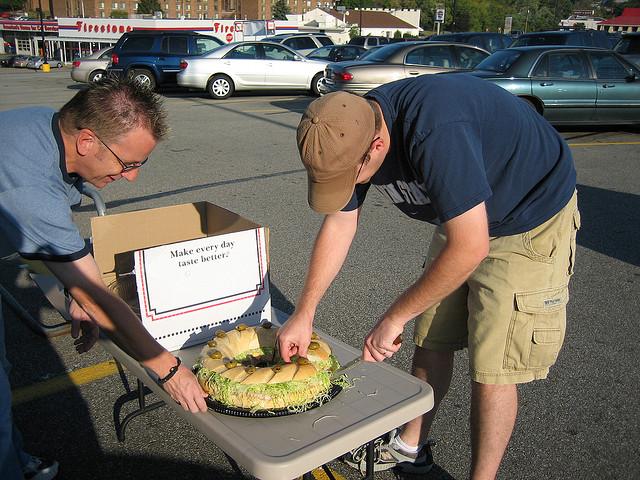What is sitting next to the sandwich?
Quick response, please. Box. What Tire store is in the foreground?
Answer briefly. Firestone. Is the man on the right cutting the sandwich?
Short answer required. Yes. 